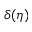<formula> <loc_0><loc_0><loc_500><loc_500>\delta ( \eta )</formula> 